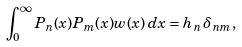Convert formula to latex. <formula><loc_0><loc_0><loc_500><loc_500>\int _ { 0 } ^ { \infty } P _ { n } ( x ) P _ { m } ( x ) w ( x ) \, d x = h _ { n } \, \delta _ { n m } ,</formula> 